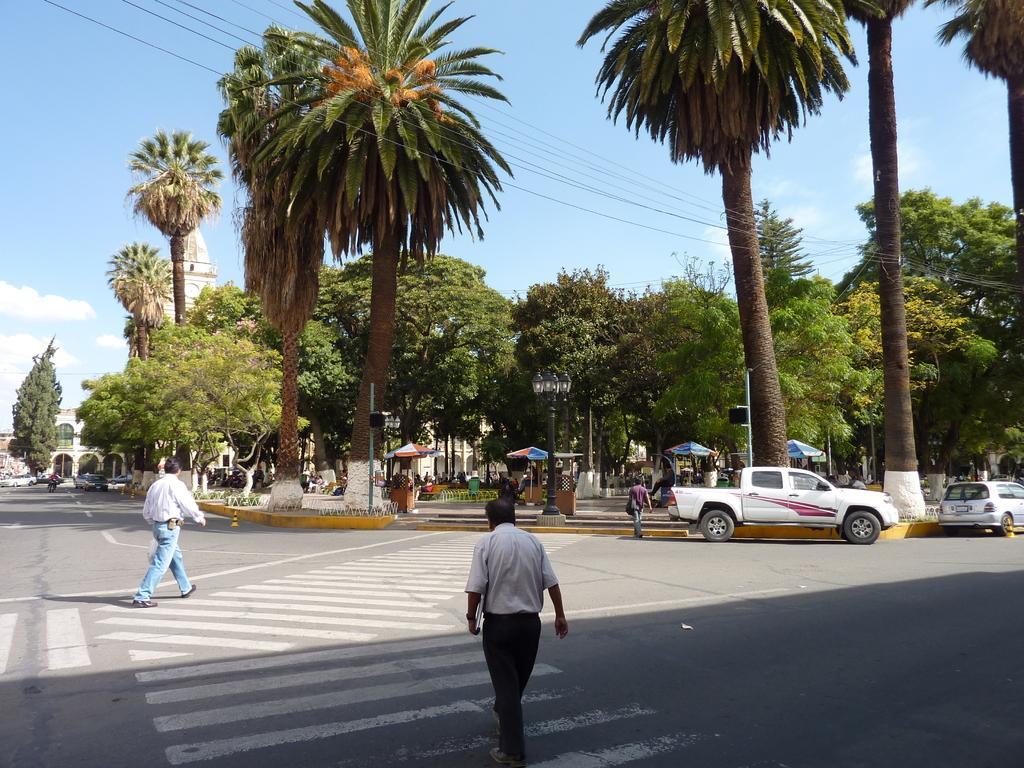In one or two sentences, can you explain what this image depicts? In this image there are few people and few vehicles are moving on the road. In the background there are trees, beneath the trees there are few people and a sky. 